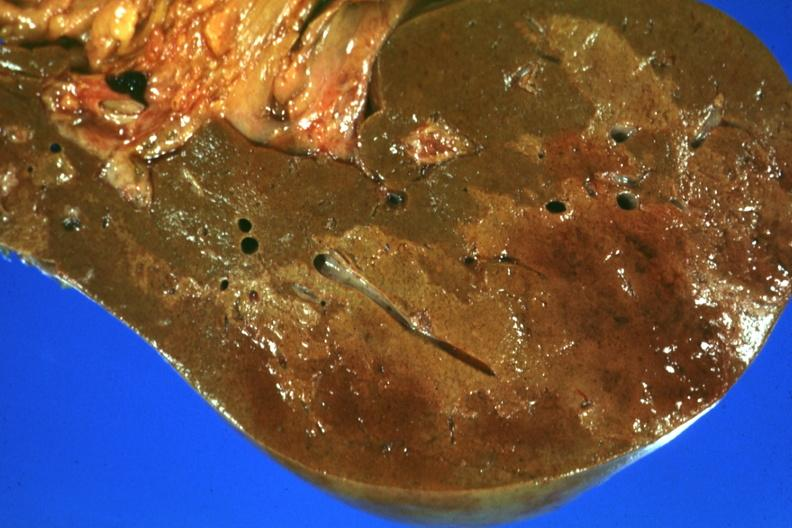what is present?
Answer the question using a single word or phrase. Liver 